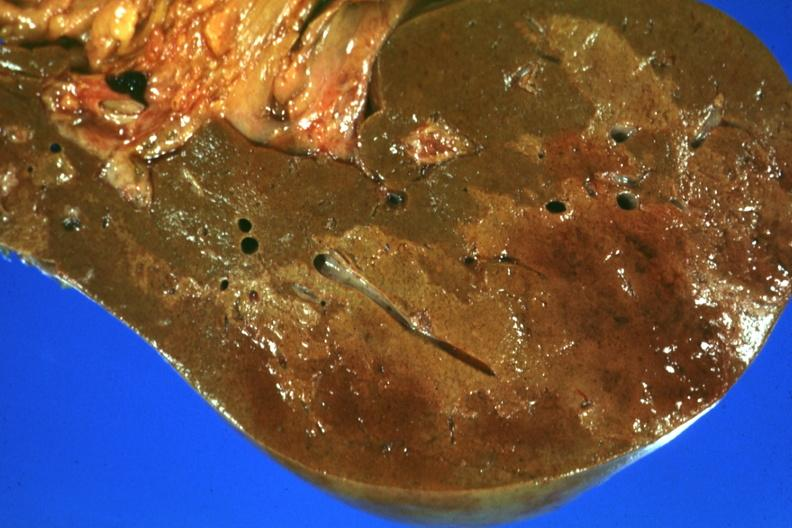what is present?
Answer the question using a single word or phrase. Liver 